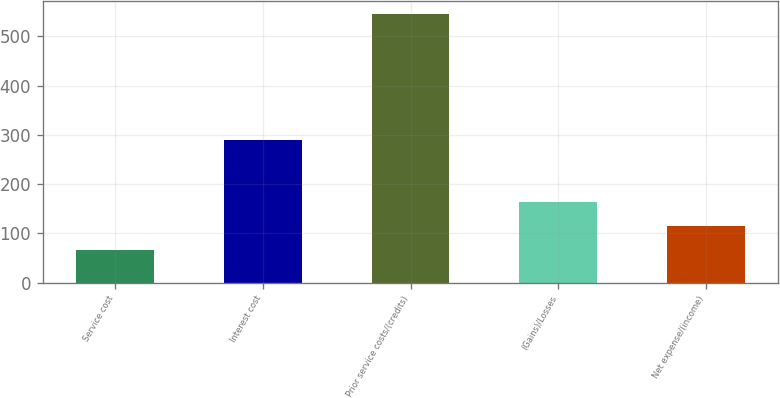Convert chart. <chart><loc_0><loc_0><loc_500><loc_500><bar_chart><fcel>Service cost<fcel>Interest cost<fcel>Prior service costs/(credits)<fcel>(Gains)/Losses<fcel>Net expense/(income)<nl><fcel>67<fcel>290<fcel>545<fcel>162.6<fcel>114.8<nl></chart> 